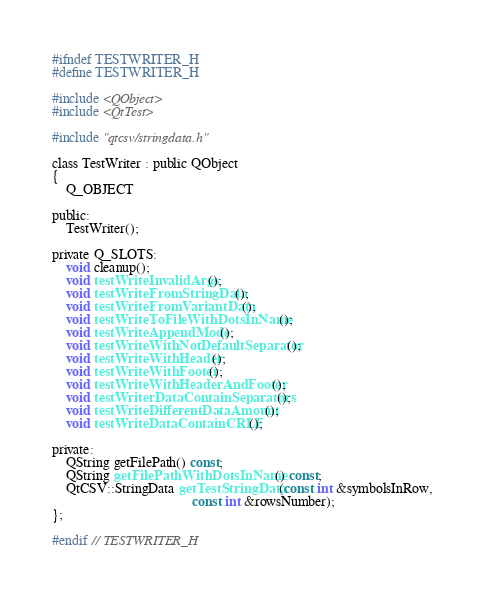Convert code to text. <code><loc_0><loc_0><loc_500><loc_500><_C_>#ifndef TESTWRITER_H
#define TESTWRITER_H

#include <QObject>
#include <QtTest>

#include "qtcsv/stringdata.h"

class TestWriter : public QObject
{
    Q_OBJECT

public:
    TestWriter();

private Q_SLOTS:
    void cleanup();
    void testWriteInvalidArgs();
    void testWriteFromStringData();
    void testWriteFromVariantData();
    void testWriteToFileWithDotsInName();
    void testWriteAppendMode();
    void testWriteWithNotDefaultSeparator();
    void testWriteWithHeader();
    void testWriteWithFooter();
    void testWriteWithHeaderAndFooter();
    void testWriterDataContainSeparators();
    void testWriteDifferentDataAmount();
    void testWriteDataContainCRLF();

private:
    QString getFilePath() const;
    QString getFilePathWithDotsInName() const;
    QtCSV::StringData getTestStringData(const int &symbolsInRow,
                                        const int &rowsNumber);
};

#endif // TESTWRITER_H
</code> 